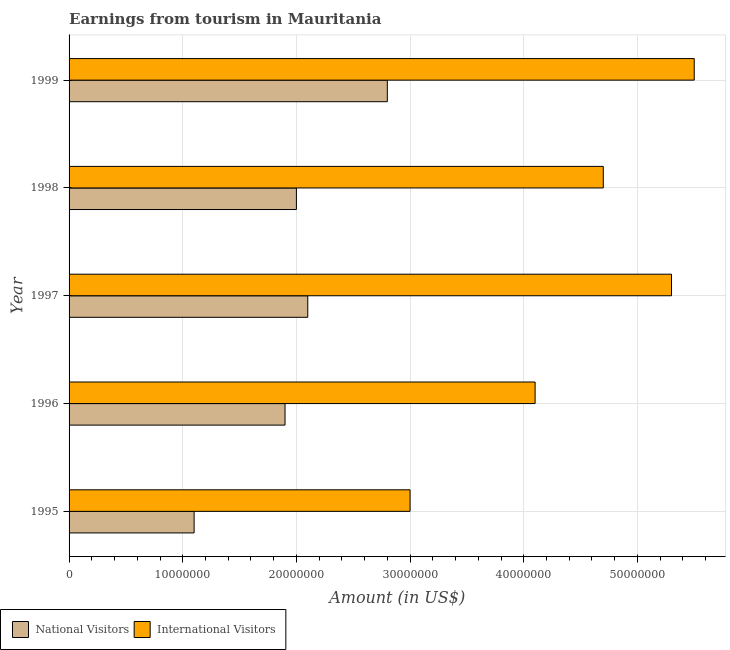How many different coloured bars are there?
Your answer should be compact. 2. How many groups of bars are there?
Your answer should be compact. 5. Are the number of bars per tick equal to the number of legend labels?
Ensure brevity in your answer.  Yes. Are the number of bars on each tick of the Y-axis equal?
Make the answer very short. Yes. How many bars are there on the 2nd tick from the bottom?
Provide a short and direct response. 2. What is the label of the 4th group of bars from the top?
Give a very brief answer. 1996. In how many cases, is the number of bars for a given year not equal to the number of legend labels?
Make the answer very short. 0. What is the amount earned from national visitors in 1997?
Keep it short and to the point. 2.10e+07. Across all years, what is the maximum amount earned from national visitors?
Your answer should be compact. 2.80e+07. Across all years, what is the minimum amount earned from national visitors?
Your answer should be compact. 1.10e+07. In which year was the amount earned from international visitors maximum?
Your answer should be very brief. 1999. What is the total amount earned from international visitors in the graph?
Give a very brief answer. 2.26e+08. What is the difference between the amount earned from international visitors in 1996 and that in 1998?
Your answer should be compact. -6.00e+06. What is the difference between the amount earned from international visitors in 1996 and the amount earned from national visitors in 1997?
Make the answer very short. 2.00e+07. What is the average amount earned from national visitors per year?
Make the answer very short. 1.98e+07. In the year 1996, what is the difference between the amount earned from international visitors and amount earned from national visitors?
Your answer should be very brief. 2.20e+07. In how many years, is the amount earned from international visitors greater than 26000000 US$?
Ensure brevity in your answer.  5. What is the ratio of the amount earned from international visitors in 1995 to that in 1996?
Make the answer very short. 0.73. Is the amount earned from international visitors in 1997 less than that in 1998?
Your response must be concise. No. Is the difference between the amount earned from national visitors in 1997 and 1999 greater than the difference between the amount earned from international visitors in 1997 and 1999?
Offer a very short reply. No. What is the difference between the highest and the lowest amount earned from international visitors?
Give a very brief answer. 2.50e+07. In how many years, is the amount earned from international visitors greater than the average amount earned from international visitors taken over all years?
Offer a very short reply. 3. What does the 2nd bar from the top in 1996 represents?
Provide a short and direct response. National Visitors. What does the 1st bar from the bottom in 1998 represents?
Your response must be concise. National Visitors. Are all the bars in the graph horizontal?
Your response must be concise. Yes. How many years are there in the graph?
Your response must be concise. 5. Are the values on the major ticks of X-axis written in scientific E-notation?
Your answer should be very brief. No. Where does the legend appear in the graph?
Keep it short and to the point. Bottom left. How many legend labels are there?
Your answer should be compact. 2. How are the legend labels stacked?
Offer a very short reply. Horizontal. What is the title of the graph?
Offer a very short reply. Earnings from tourism in Mauritania. What is the Amount (in US$) of National Visitors in 1995?
Offer a terse response. 1.10e+07. What is the Amount (in US$) of International Visitors in 1995?
Give a very brief answer. 3.00e+07. What is the Amount (in US$) of National Visitors in 1996?
Your answer should be very brief. 1.90e+07. What is the Amount (in US$) of International Visitors in 1996?
Your answer should be very brief. 4.10e+07. What is the Amount (in US$) of National Visitors in 1997?
Provide a short and direct response. 2.10e+07. What is the Amount (in US$) of International Visitors in 1997?
Offer a terse response. 5.30e+07. What is the Amount (in US$) in National Visitors in 1998?
Offer a very short reply. 2.00e+07. What is the Amount (in US$) of International Visitors in 1998?
Your answer should be compact. 4.70e+07. What is the Amount (in US$) in National Visitors in 1999?
Give a very brief answer. 2.80e+07. What is the Amount (in US$) of International Visitors in 1999?
Your answer should be very brief. 5.50e+07. Across all years, what is the maximum Amount (in US$) of National Visitors?
Provide a short and direct response. 2.80e+07. Across all years, what is the maximum Amount (in US$) of International Visitors?
Provide a short and direct response. 5.50e+07. Across all years, what is the minimum Amount (in US$) in National Visitors?
Give a very brief answer. 1.10e+07. Across all years, what is the minimum Amount (in US$) of International Visitors?
Provide a succinct answer. 3.00e+07. What is the total Amount (in US$) in National Visitors in the graph?
Your answer should be compact. 9.90e+07. What is the total Amount (in US$) of International Visitors in the graph?
Your response must be concise. 2.26e+08. What is the difference between the Amount (in US$) of National Visitors in 1995 and that in 1996?
Provide a short and direct response. -8.00e+06. What is the difference between the Amount (in US$) of International Visitors in 1995 and that in 1996?
Your answer should be compact. -1.10e+07. What is the difference between the Amount (in US$) in National Visitors in 1995 and that in 1997?
Make the answer very short. -1.00e+07. What is the difference between the Amount (in US$) in International Visitors in 1995 and that in 1997?
Give a very brief answer. -2.30e+07. What is the difference between the Amount (in US$) in National Visitors in 1995 and that in 1998?
Offer a terse response. -9.00e+06. What is the difference between the Amount (in US$) of International Visitors in 1995 and that in 1998?
Provide a succinct answer. -1.70e+07. What is the difference between the Amount (in US$) in National Visitors in 1995 and that in 1999?
Provide a short and direct response. -1.70e+07. What is the difference between the Amount (in US$) of International Visitors in 1995 and that in 1999?
Provide a short and direct response. -2.50e+07. What is the difference between the Amount (in US$) of National Visitors in 1996 and that in 1997?
Make the answer very short. -2.00e+06. What is the difference between the Amount (in US$) in International Visitors in 1996 and that in 1997?
Provide a succinct answer. -1.20e+07. What is the difference between the Amount (in US$) of International Visitors in 1996 and that in 1998?
Provide a short and direct response. -6.00e+06. What is the difference between the Amount (in US$) in National Visitors in 1996 and that in 1999?
Your answer should be compact. -9.00e+06. What is the difference between the Amount (in US$) of International Visitors in 1996 and that in 1999?
Provide a short and direct response. -1.40e+07. What is the difference between the Amount (in US$) of National Visitors in 1997 and that in 1999?
Keep it short and to the point. -7.00e+06. What is the difference between the Amount (in US$) in International Visitors in 1997 and that in 1999?
Provide a short and direct response. -2.00e+06. What is the difference between the Amount (in US$) in National Visitors in 1998 and that in 1999?
Make the answer very short. -8.00e+06. What is the difference between the Amount (in US$) in International Visitors in 1998 and that in 1999?
Provide a short and direct response. -8.00e+06. What is the difference between the Amount (in US$) of National Visitors in 1995 and the Amount (in US$) of International Visitors in 1996?
Give a very brief answer. -3.00e+07. What is the difference between the Amount (in US$) of National Visitors in 1995 and the Amount (in US$) of International Visitors in 1997?
Offer a very short reply. -4.20e+07. What is the difference between the Amount (in US$) of National Visitors in 1995 and the Amount (in US$) of International Visitors in 1998?
Provide a succinct answer. -3.60e+07. What is the difference between the Amount (in US$) in National Visitors in 1995 and the Amount (in US$) in International Visitors in 1999?
Give a very brief answer. -4.40e+07. What is the difference between the Amount (in US$) of National Visitors in 1996 and the Amount (in US$) of International Visitors in 1997?
Provide a short and direct response. -3.40e+07. What is the difference between the Amount (in US$) of National Visitors in 1996 and the Amount (in US$) of International Visitors in 1998?
Make the answer very short. -2.80e+07. What is the difference between the Amount (in US$) in National Visitors in 1996 and the Amount (in US$) in International Visitors in 1999?
Offer a terse response. -3.60e+07. What is the difference between the Amount (in US$) in National Visitors in 1997 and the Amount (in US$) in International Visitors in 1998?
Make the answer very short. -2.60e+07. What is the difference between the Amount (in US$) in National Visitors in 1997 and the Amount (in US$) in International Visitors in 1999?
Provide a succinct answer. -3.40e+07. What is the difference between the Amount (in US$) in National Visitors in 1998 and the Amount (in US$) in International Visitors in 1999?
Your response must be concise. -3.50e+07. What is the average Amount (in US$) of National Visitors per year?
Offer a terse response. 1.98e+07. What is the average Amount (in US$) in International Visitors per year?
Keep it short and to the point. 4.52e+07. In the year 1995, what is the difference between the Amount (in US$) in National Visitors and Amount (in US$) in International Visitors?
Ensure brevity in your answer.  -1.90e+07. In the year 1996, what is the difference between the Amount (in US$) in National Visitors and Amount (in US$) in International Visitors?
Your answer should be very brief. -2.20e+07. In the year 1997, what is the difference between the Amount (in US$) of National Visitors and Amount (in US$) of International Visitors?
Ensure brevity in your answer.  -3.20e+07. In the year 1998, what is the difference between the Amount (in US$) in National Visitors and Amount (in US$) in International Visitors?
Make the answer very short. -2.70e+07. In the year 1999, what is the difference between the Amount (in US$) in National Visitors and Amount (in US$) in International Visitors?
Give a very brief answer. -2.70e+07. What is the ratio of the Amount (in US$) of National Visitors in 1995 to that in 1996?
Make the answer very short. 0.58. What is the ratio of the Amount (in US$) in International Visitors in 1995 to that in 1996?
Provide a succinct answer. 0.73. What is the ratio of the Amount (in US$) of National Visitors in 1995 to that in 1997?
Your answer should be compact. 0.52. What is the ratio of the Amount (in US$) of International Visitors in 1995 to that in 1997?
Your answer should be compact. 0.57. What is the ratio of the Amount (in US$) of National Visitors in 1995 to that in 1998?
Give a very brief answer. 0.55. What is the ratio of the Amount (in US$) in International Visitors in 1995 to that in 1998?
Give a very brief answer. 0.64. What is the ratio of the Amount (in US$) in National Visitors in 1995 to that in 1999?
Your answer should be compact. 0.39. What is the ratio of the Amount (in US$) in International Visitors in 1995 to that in 1999?
Give a very brief answer. 0.55. What is the ratio of the Amount (in US$) of National Visitors in 1996 to that in 1997?
Give a very brief answer. 0.9. What is the ratio of the Amount (in US$) in International Visitors in 1996 to that in 1997?
Ensure brevity in your answer.  0.77. What is the ratio of the Amount (in US$) in National Visitors in 1996 to that in 1998?
Your answer should be very brief. 0.95. What is the ratio of the Amount (in US$) of International Visitors in 1996 to that in 1998?
Give a very brief answer. 0.87. What is the ratio of the Amount (in US$) of National Visitors in 1996 to that in 1999?
Your response must be concise. 0.68. What is the ratio of the Amount (in US$) of International Visitors in 1996 to that in 1999?
Offer a terse response. 0.75. What is the ratio of the Amount (in US$) in International Visitors in 1997 to that in 1998?
Offer a terse response. 1.13. What is the ratio of the Amount (in US$) of National Visitors in 1997 to that in 1999?
Offer a very short reply. 0.75. What is the ratio of the Amount (in US$) in International Visitors in 1997 to that in 1999?
Give a very brief answer. 0.96. What is the ratio of the Amount (in US$) of International Visitors in 1998 to that in 1999?
Ensure brevity in your answer.  0.85. What is the difference between the highest and the lowest Amount (in US$) of National Visitors?
Keep it short and to the point. 1.70e+07. What is the difference between the highest and the lowest Amount (in US$) of International Visitors?
Ensure brevity in your answer.  2.50e+07. 